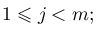Convert formula to latex. <formula><loc_0><loc_0><loc_500><loc_500>1 \leqslant j < m ;</formula> 